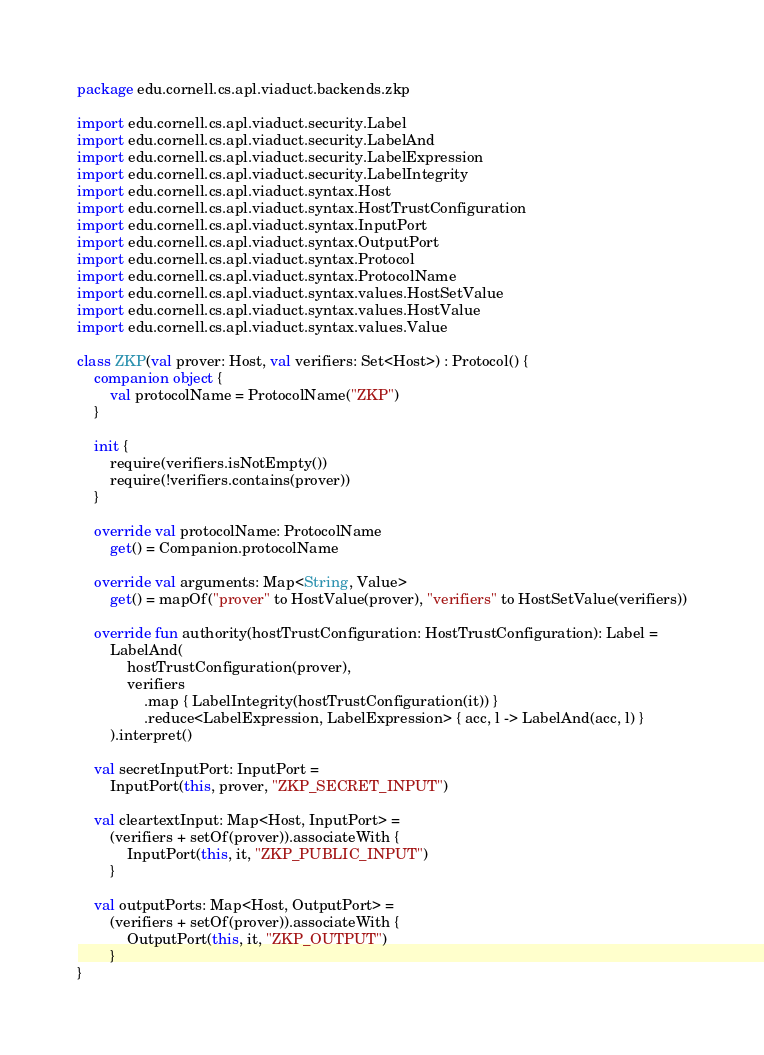Convert code to text. <code><loc_0><loc_0><loc_500><loc_500><_Kotlin_>package edu.cornell.cs.apl.viaduct.backends.zkp

import edu.cornell.cs.apl.viaduct.security.Label
import edu.cornell.cs.apl.viaduct.security.LabelAnd
import edu.cornell.cs.apl.viaduct.security.LabelExpression
import edu.cornell.cs.apl.viaduct.security.LabelIntegrity
import edu.cornell.cs.apl.viaduct.syntax.Host
import edu.cornell.cs.apl.viaduct.syntax.HostTrustConfiguration
import edu.cornell.cs.apl.viaduct.syntax.InputPort
import edu.cornell.cs.apl.viaduct.syntax.OutputPort
import edu.cornell.cs.apl.viaduct.syntax.Protocol
import edu.cornell.cs.apl.viaduct.syntax.ProtocolName
import edu.cornell.cs.apl.viaduct.syntax.values.HostSetValue
import edu.cornell.cs.apl.viaduct.syntax.values.HostValue
import edu.cornell.cs.apl.viaduct.syntax.values.Value

class ZKP(val prover: Host, val verifiers: Set<Host>) : Protocol() {
    companion object {
        val protocolName = ProtocolName("ZKP")
    }

    init {
        require(verifiers.isNotEmpty())
        require(!verifiers.contains(prover))
    }

    override val protocolName: ProtocolName
        get() = Companion.protocolName

    override val arguments: Map<String, Value>
        get() = mapOf("prover" to HostValue(prover), "verifiers" to HostSetValue(verifiers))

    override fun authority(hostTrustConfiguration: HostTrustConfiguration): Label =
        LabelAnd(
            hostTrustConfiguration(prover),
            verifiers
                .map { LabelIntegrity(hostTrustConfiguration(it)) }
                .reduce<LabelExpression, LabelExpression> { acc, l -> LabelAnd(acc, l) }
        ).interpret()

    val secretInputPort: InputPort =
        InputPort(this, prover, "ZKP_SECRET_INPUT")

    val cleartextInput: Map<Host, InputPort> =
        (verifiers + setOf(prover)).associateWith {
            InputPort(this, it, "ZKP_PUBLIC_INPUT")
        }

    val outputPorts: Map<Host, OutputPort> =
        (verifiers + setOf(prover)).associateWith {
            OutputPort(this, it, "ZKP_OUTPUT")
        }
}
</code> 